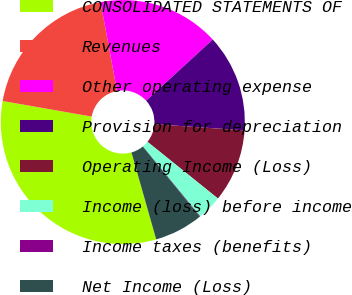Convert chart. <chart><loc_0><loc_0><loc_500><loc_500><pie_chart><fcel>CONSOLIDATED STATEMENTS OF<fcel>Revenues<fcel>Other operating expense<fcel>Provision for depreciation<fcel>Operating Income (Loss)<fcel>Income (loss) before income<fcel>Income taxes (benefits)<fcel>Net Income (Loss)<nl><fcel>32.16%<fcel>19.32%<fcel>16.11%<fcel>12.9%<fcel>9.69%<fcel>3.27%<fcel>0.06%<fcel>6.48%<nl></chart> 